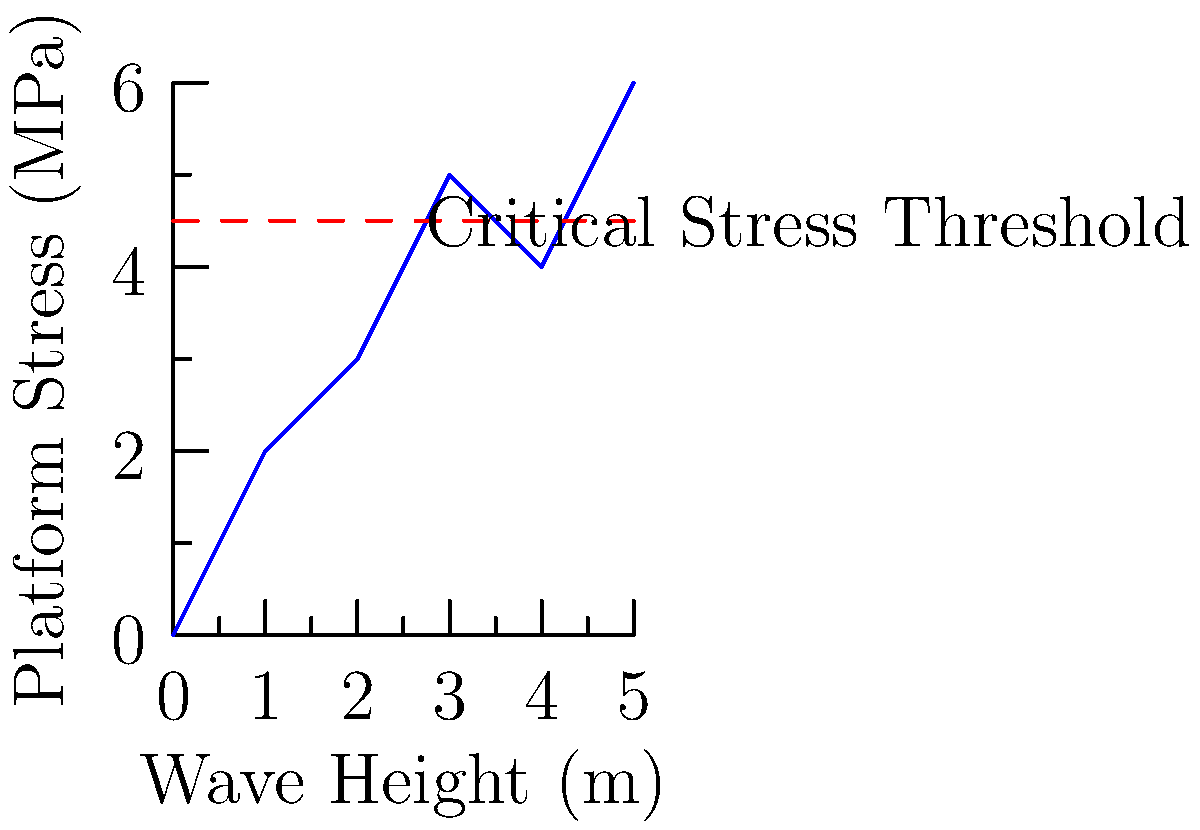Based on the schematic drawing showing the relationship between wave height and platform stress for an offshore oil platform, at what approximate wave height does the platform stress exceed the critical stress threshold of 4.5 MPa? To determine the wave height at which the platform stress exceeds the critical threshold, we need to follow these steps:

1. Identify the critical stress threshold: 4.5 MPa (shown by the red dashed line).

2. Locate the intersection point of the blue curve (representing platform stress) and the red dashed line (critical stress threshold).

3. Project this intersection point onto the x-axis to find the corresponding wave height.

4. Estimate the wave height value:
   - The intersection occurs between x=2 and x=3 on the graph.
   - It appears to be closer to x=2.5.

5. Interpret the result:
   - The x-axis represents wave height in meters.
   - Therefore, the platform stress exceeds the critical threshold at approximately 2.5 meters wave height.

This analysis suggests that waves higher than about 2.5 meters may compromise the structural integrity of the offshore oil platform, necessitating careful monitoring and potential mitigation measures during such conditions.
Answer: Approximately 2.5 meters 